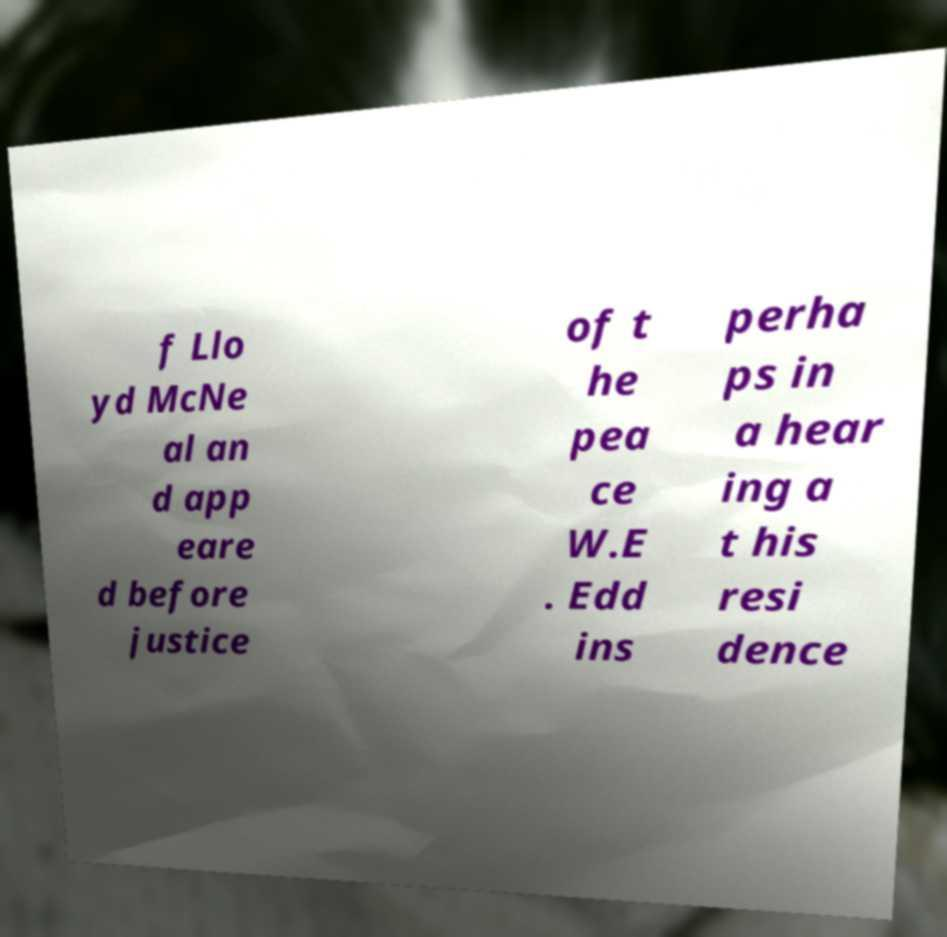Can you accurately transcribe the text from the provided image for me? f Llo yd McNe al an d app eare d before justice of t he pea ce W.E . Edd ins perha ps in a hear ing a t his resi dence 